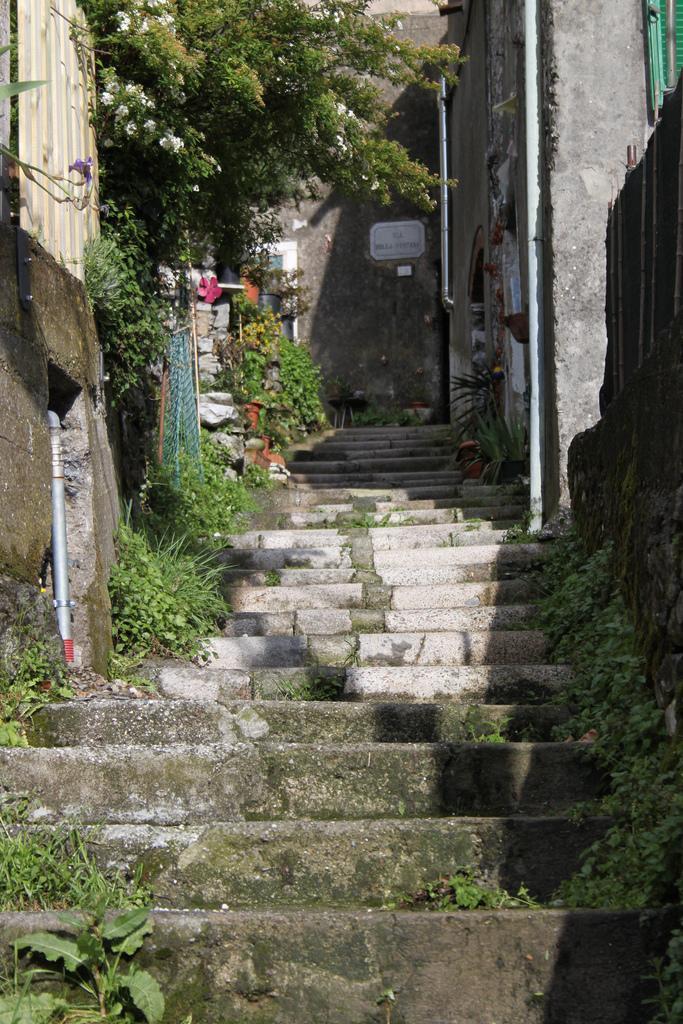Please provide a concise description of this image. In this image we can see the stairs. And we can see the plants, trees. And we can see the concrete sheets. And we can see the pipelines. And we can see one board and some text is written on it. 